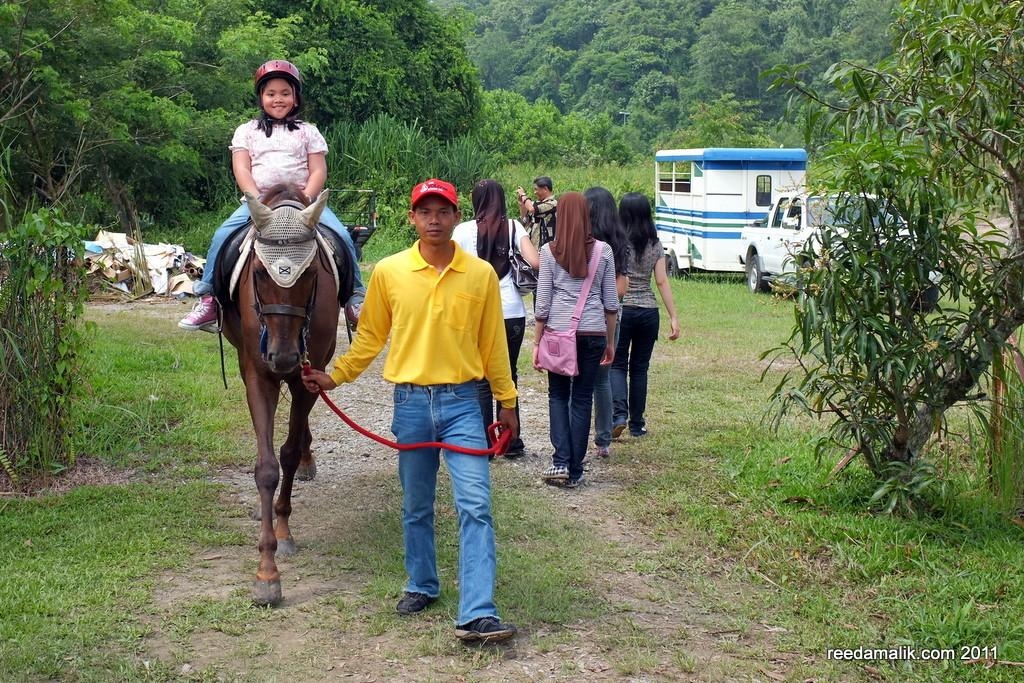How many people are present in the image? There are many people in the image. What is the girl in the image doing? The girl is sitting on a horse. What is the person doing in relation to the horse? The person is catching the horse. What type of bird can be seen flying in the image? There is no bird present in the image. Who is the expert on horse riding in the image? The image does not provide information about any experts on horse riding. 